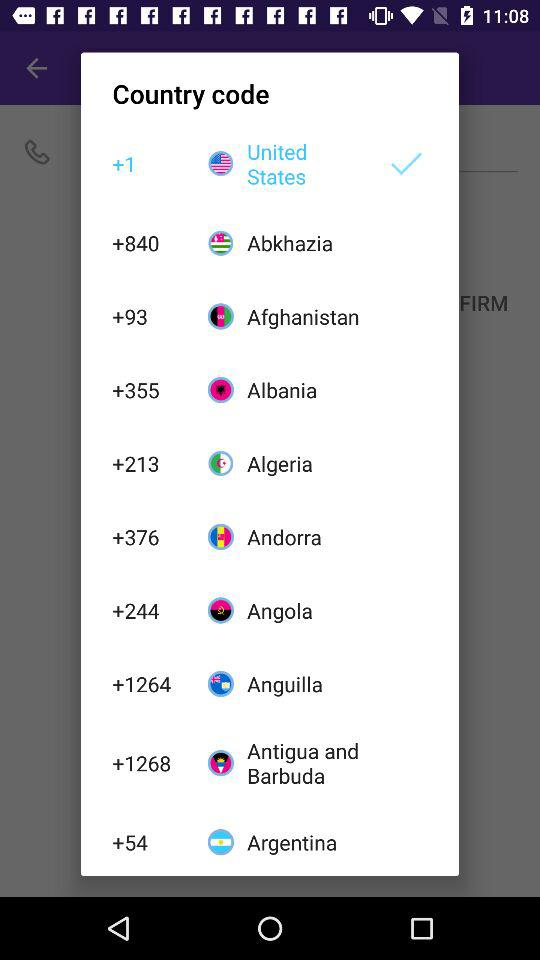What is the country code of Albania? The country code of Albania is +355. 